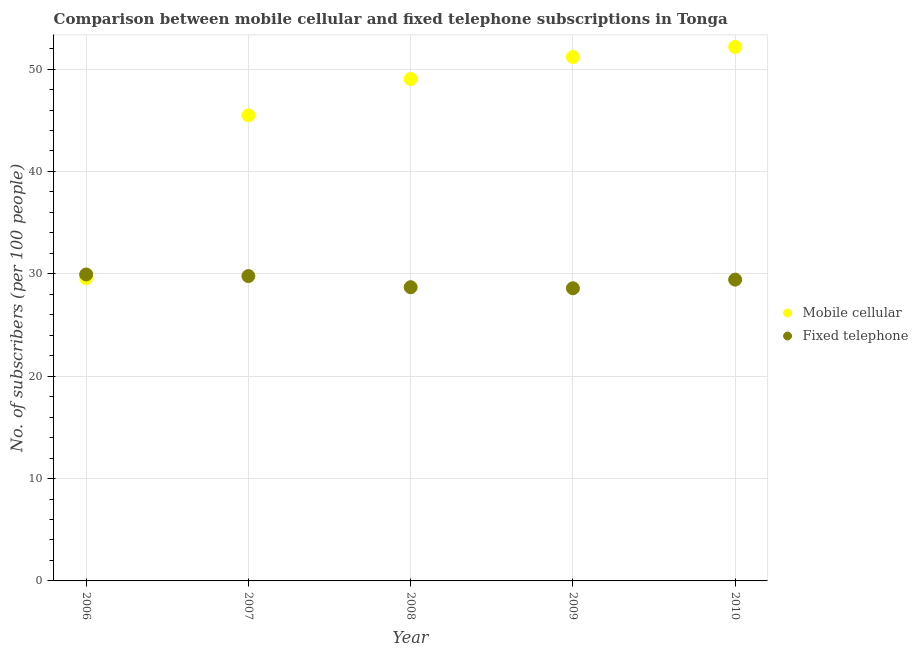Is the number of dotlines equal to the number of legend labels?
Make the answer very short. Yes. What is the number of fixed telephone subscribers in 2006?
Give a very brief answer. 29.94. Across all years, what is the maximum number of fixed telephone subscribers?
Make the answer very short. 29.94. Across all years, what is the minimum number of fixed telephone subscribers?
Keep it short and to the point. 28.59. What is the total number of fixed telephone subscribers in the graph?
Provide a succinct answer. 146.43. What is the difference between the number of mobile cellular subscribers in 2007 and that in 2010?
Make the answer very short. -6.68. What is the difference between the number of mobile cellular subscribers in 2007 and the number of fixed telephone subscribers in 2006?
Your answer should be compact. 15.55. What is the average number of fixed telephone subscribers per year?
Offer a very short reply. 29.29. In the year 2008, what is the difference between the number of fixed telephone subscribers and number of mobile cellular subscribers?
Ensure brevity in your answer.  -20.33. What is the ratio of the number of mobile cellular subscribers in 2009 to that in 2010?
Offer a terse response. 0.98. Is the difference between the number of fixed telephone subscribers in 2006 and 2009 greater than the difference between the number of mobile cellular subscribers in 2006 and 2009?
Offer a very short reply. Yes. What is the difference between the highest and the second highest number of fixed telephone subscribers?
Your response must be concise. 0.16. What is the difference between the highest and the lowest number of fixed telephone subscribers?
Your response must be concise. 1.35. In how many years, is the number of mobile cellular subscribers greater than the average number of mobile cellular subscribers taken over all years?
Ensure brevity in your answer.  3. Is the sum of the number of mobile cellular subscribers in 2009 and 2010 greater than the maximum number of fixed telephone subscribers across all years?
Your answer should be very brief. Yes. Does the number of mobile cellular subscribers monotonically increase over the years?
Offer a terse response. Yes. Is the number of mobile cellular subscribers strictly greater than the number of fixed telephone subscribers over the years?
Ensure brevity in your answer.  No. How many dotlines are there?
Ensure brevity in your answer.  2. How many years are there in the graph?
Your answer should be very brief. 5. How many legend labels are there?
Keep it short and to the point. 2. How are the legend labels stacked?
Ensure brevity in your answer.  Vertical. What is the title of the graph?
Your answer should be compact. Comparison between mobile cellular and fixed telephone subscriptions in Tonga. Does "Net savings(excluding particulate emission damage)" appear as one of the legend labels in the graph?
Provide a short and direct response. No. What is the label or title of the X-axis?
Your answer should be very brief. Year. What is the label or title of the Y-axis?
Provide a short and direct response. No. of subscribers (per 100 people). What is the No. of subscribers (per 100 people) in Mobile cellular in 2006?
Your answer should be compact. 29.57. What is the No. of subscribers (per 100 people) in Fixed telephone in 2006?
Provide a succinct answer. 29.94. What is the No. of subscribers (per 100 people) in Mobile cellular in 2007?
Your answer should be very brief. 45.48. What is the No. of subscribers (per 100 people) of Fixed telephone in 2007?
Provide a succinct answer. 29.78. What is the No. of subscribers (per 100 people) in Mobile cellular in 2008?
Make the answer very short. 49.03. What is the No. of subscribers (per 100 people) in Fixed telephone in 2008?
Offer a terse response. 28.69. What is the No. of subscribers (per 100 people) in Mobile cellular in 2009?
Give a very brief answer. 51.18. What is the No. of subscribers (per 100 people) in Fixed telephone in 2009?
Ensure brevity in your answer.  28.59. What is the No. of subscribers (per 100 people) in Mobile cellular in 2010?
Offer a terse response. 52.16. What is the No. of subscribers (per 100 people) in Fixed telephone in 2010?
Provide a succinct answer. 29.43. Across all years, what is the maximum No. of subscribers (per 100 people) of Mobile cellular?
Make the answer very short. 52.16. Across all years, what is the maximum No. of subscribers (per 100 people) of Fixed telephone?
Give a very brief answer. 29.94. Across all years, what is the minimum No. of subscribers (per 100 people) of Mobile cellular?
Offer a very short reply. 29.57. Across all years, what is the minimum No. of subscribers (per 100 people) of Fixed telephone?
Your response must be concise. 28.59. What is the total No. of subscribers (per 100 people) of Mobile cellular in the graph?
Your response must be concise. 227.43. What is the total No. of subscribers (per 100 people) in Fixed telephone in the graph?
Keep it short and to the point. 146.43. What is the difference between the No. of subscribers (per 100 people) in Mobile cellular in 2006 and that in 2007?
Ensure brevity in your answer.  -15.91. What is the difference between the No. of subscribers (per 100 people) in Fixed telephone in 2006 and that in 2007?
Your answer should be compact. 0.16. What is the difference between the No. of subscribers (per 100 people) of Mobile cellular in 2006 and that in 2008?
Provide a succinct answer. -19.45. What is the difference between the No. of subscribers (per 100 people) of Fixed telephone in 2006 and that in 2008?
Make the answer very short. 1.24. What is the difference between the No. of subscribers (per 100 people) in Mobile cellular in 2006 and that in 2009?
Offer a terse response. -21.61. What is the difference between the No. of subscribers (per 100 people) in Fixed telephone in 2006 and that in 2009?
Provide a short and direct response. 1.35. What is the difference between the No. of subscribers (per 100 people) in Mobile cellular in 2006 and that in 2010?
Keep it short and to the point. -22.59. What is the difference between the No. of subscribers (per 100 people) in Fixed telephone in 2006 and that in 2010?
Provide a succinct answer. 0.5. What is the difference between the No. of subscribers (per 100 people) in Mobile cellular in 2007 and that in 2008?
Give a very brief answer. -3.54. What is the difference between the No. of subscribers (per 100 people) of Fixed telephone in 2007 and that in 2008?
Give a very brief answer. 1.09. What is the difference between the No. of subscribers (per 100 people) of Mobile cellular in 2007 and that in 2009?
Provide a succinct answer. -5.7. What is the difference between the No. of subscribers (per 100 people) of Fixed telephone in 2007 and that in 2009?
Provide a succinct answer. 1.19. What is the difference between the No. of subscribers (per 100 people) of Mobile cellular in 2007 and that in 2010?
Give a very brief answer. -6.68. What is the difference between the No. of subscribers (per 100 people) of Fixed telephone in 2007 and that in 2010?
Offer a terse response. 0.35. What is the difference between the No. of subscribers (per 100 people) of Mobile cellular in 2008 and that in 2009?
Your response must be concise. -2.15. What is the difference between the No. of subscribers (per 100 people) of Fixed telephone in 2008 and that in 2009?
Make the answer very short. 0.11. What is the difference between the No. of subscribers (per 100 people) in Mobile cellular in 2008 and that in 2010?
Give a very brief answer. -3.14. What is the difference between the No. of subscribers (per 100 people) of Fixed telephone in 2008 and that in 2010?
Provide a short and direct response. -0.74. What is the difference between the No. of subscribers (per 100 people) in Mobile cellular in 2009 and that in 2010?
Offer a terse response. -0.98. What is the difference between the No. of subscribers (per 100 people) of Fixed telephone in 2009 and that in 2010?
Provide a short and direct response. -0.85. What is the difference between the No. of subscribers (per 100 people) in Mobile cellular in 2006 and the No. of subscribers (per 100 people) in Fixed telephone in 2007?
Provide a succinct answer. -0.21. What is the difference between the No. of subscribers (per 100 people) of Mobile cellular in 2006 and the No. of subscribers (per 100 people) of Fixed telephone in 2008?
Ensure brevity in your answer.  0.88. What is the difference between the No. of subscribers (per 100 people) of Mobile cellular in 2006 and the No. of subscribers (per 100 people) of Fixed telephone in 2009?
Offer a terse response. 0.99. What is the difference between the No. of subscribers (per 100 people) of Mobile cellular in 2006 and the No. of subscribers (per 100 people) of Fixed telephone in 2010?
Ensure brevity in your answer.  0.14. What is the difference between the No. of subscribers (per 100 people) in Mobile cellular in 2007 and the No. of subscribers (per 100 people) in Fixed telephone in 2008?
Your answer should be compact. 16.79. What is the difference between the No. of subscribers (per 100 people) in Mobile cellular in 2007 and the No. of subscribers (per 100 people) in Fixed telephone in 2009?
Provide a short and direct response. 16.9. What is the difference between the No. of subscribers (per 100 people) in Mobile cellular in 2007 and the No. of subscribers (per 100 people) in Fixed telephone in 2010?
Offer a very short reply. 16.05. What is the difference between the No. of subscribers (per 100 people) of Mobile cellular in 2008 and the No. of subscribers (per 100 people) of Fixed telephone in 2009?
Your response must be concise. 20.44. What is the difference between the No. of subscribers (per 100 people) of Mobile cellular in 2008 and the No. of subscribers (per 100 people) of Fixed telephone in 2010?
Provide a succinct answer. 19.59. What is the difference between the No. of subscribers (per 100 people) in Mobile cellular in 2009 and the No. of subscribers (per 100 people) in Fixed telephone in 2010?
Offer a very short reply. 21.75. What is the average No. of subscribers (per 100 people) in Mobile cellular per year?
Your answer should be very brief. 45.49. What is the average No. of subscribers (per 100 people) in Fixed telephone per year?
Offer a terse response. 29.29. In the year 2006, what is the difference between the No. of subscribers (per 100 people) in Mobile cellular and No. of subscribers (per 100 people) in Fixed telephone?
Make the answer very short. -0.36. In the year 2007, what is the difference between the No. of subscribers (per 100 people) of Mobile cellular and No. of subscribers (per 100 people) of Fixed telephone?
Make the answer very short. 15.7. In the year 2008, what is the difference between the No. of subscribers (per 100 people) of Mobile cellular and No. of subscribers (per 100 people) of Fixed telephone?
Make the answer very short. 20.33. In the year 2009, what is the difference between the No. of subscribers (per 100 people) in Mobile cellular and No. of subscribers (per 100 people) in Fixed telephone?
Ensure brevity in your answer.  22.59. In the year 2010, what is the difference between the No. of subscribers (per 100 people) in Mobile cellular and No. of subscribers (per 100 people) in Fixed telephone?
Your answer should be compact. 22.73. What is the ratio of the No. of subscribers (per 100 people) in Mobile cellular in 2006 to that in 2007?
Your answer should be compact. 0.65. What is the ratio of the No. of subscribers (per 100 people) in Fixed telephone in 2006 to that in 2007?
Offer a terse response. 1.01. What is the ratio of the No. of subscribers (per 100 people) in Mobile cellular in 2006 to that in 2008?
Provide a succinct answer. 0.6. What is the ratio of the No. of subscribers (per 100 people) in Fixed telephone in 2006 to that in 2008?
Make the answer very short. 1.04. What is the ratio of the No. of subscribers (per 100 people) of Mobile cellular in 2006 to that in 2009?
Your answer should be very brief. 0.58. What is the ratio of the No. of subscribers (per 100 people) of Fixed telephone in 2006 to that in 2009?
Offer a terse response. 1.05. What is the ratio of the No. of subscribers (per 100 people) in Mobile cellular in 2006 to that in 2010?
Your answer should be very brief. 0.57. What is the ratio of the No. of subscribers (per 100 people) in Fixed telephone in 2006 to that in 2010?
Your answer should be very brief. 1.02. What is the ratio of the No. of subscribers (per 100 people) of Mobile cellular in 2007 to that in 2008?
Your response must be concise. 0.93. What is the ratio of the No. of subscribers (per 100 people) in Fixed telephone in 2007 to that in 2008?
Give a very brief answer. 1.04. What is the ratio of the No. of subscribers (per 100 people) in Mobile cellular in 2007 to that in 2009?
Offer a very short reply. 0.89. What is the ratio of the No. of subscribers (per 100 people) of Fixed telephone in 2007 to that in 2009?
Keep it short and to the point. 1.04. What is the ratio of the No. of subscribers (per 100 people) in Mobile cellular in 2007 to that in 2010?
Your answer should be very brief. 0.87. What is the ratio of the No. of subscribers (per 100 people) of Fixed telephone in 2007 to that in 2010?
Your answer should be compact. 1.01. What is the ratio of the No. of subscribers (per 100 people) in Mobile cellular in 2008 to that in 2009?
Offer a terse response. 0.96. What is the ratio of the No. of subscribers (per 100 people) in Mobile cellular in 2008 to that in 2010?
Ensure brevity in your answer.  0.94. What is the ratio of the No. of subscribers (per 100 people) of Fixed telephone in 2008 to that in 2010?
Your answer should be very brief. 0.97. What is the ratio of the No. of subscribers (per 100 people) in Mobile cellular in 2009 to that in 2010?
Give a very brief answer. 0.98. What is the ratio of the No. of subscribers (per 100 people) of Fixed telephone in 2009 to that in 2010?
Your response must be concise. 0.97. What is the difference between the highest and the second highest No. of subscribers (per 100 people) of Mobile cellular?
Make the answer very short. 0.98. What is the difference between the highest and the second highest No. of subscribers (per 100 people) of Fixed telephone?
Provide a short and direct response. 0.16. What is the difference between the highest and the lowest No. of subscribers (per 100 people) of Mobile cellular?
Give a very brief answer. 22.59. What is the difference between the highest and the lowest No. of subscribers (per 100 people) in Fixed telephone?
Provide a short and direct response. 1.35. 